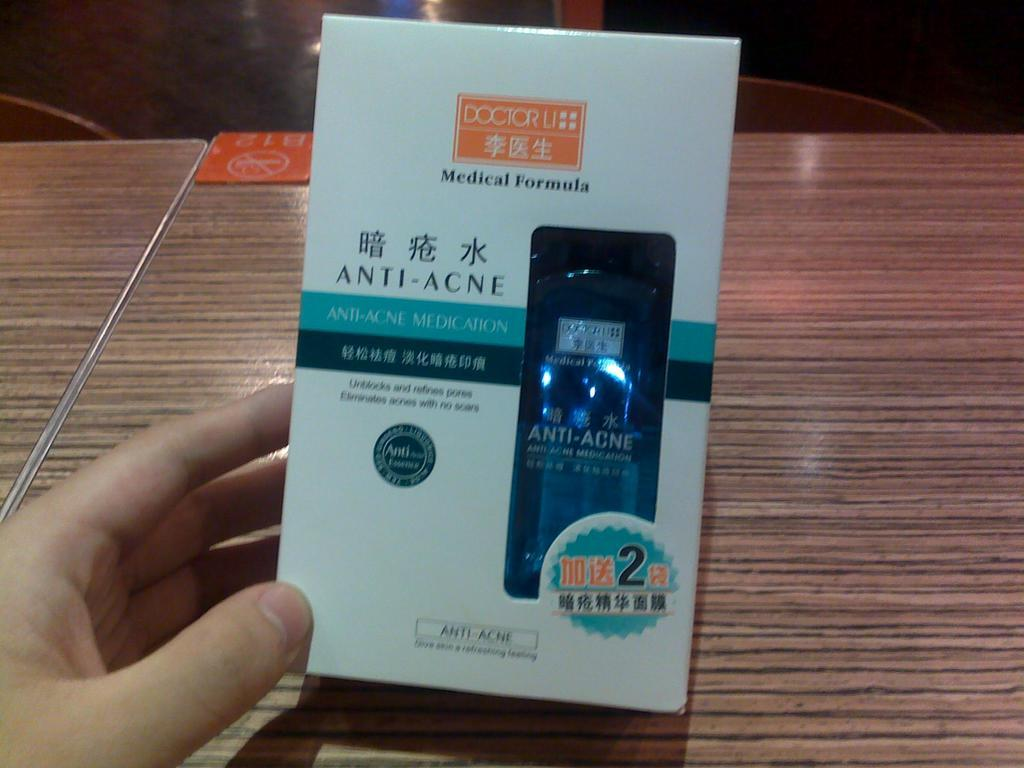<image>
Write a terse but informative summary of the picture. A bottle of Anti-Acne Medication made by Doctor Li. 